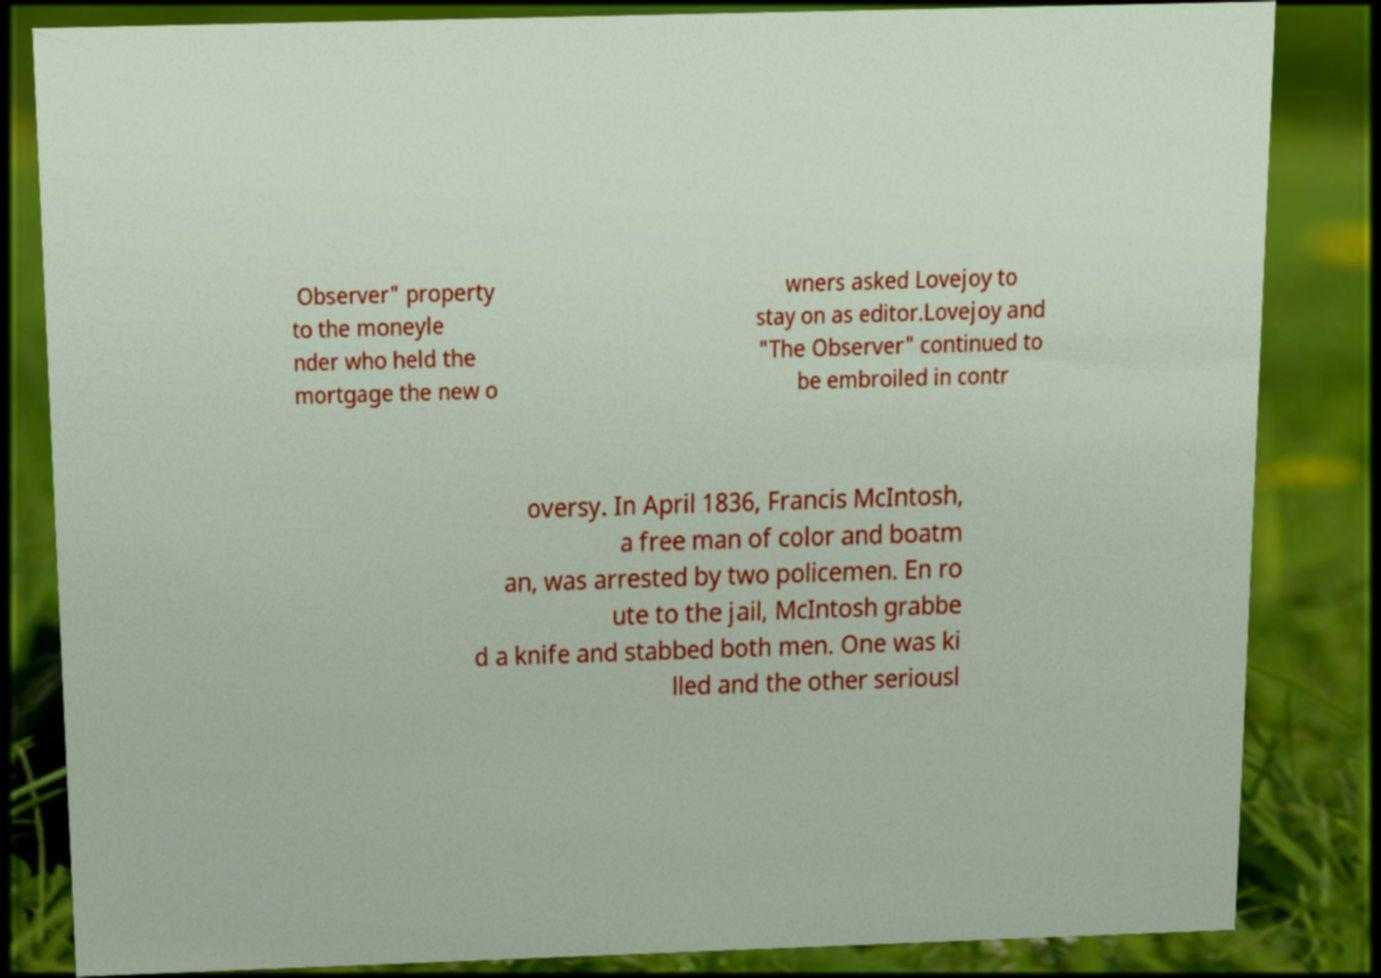There's text embedded in this image that I need extracted. Can you transcribe it verbatim? Observer" property to the moneyle nder who held the mortgage the new o wners asked Lovejoy to stay on as editor.Lovejoy and "The Observer" continued to be embroiled in contr oversy. In April 1836, Francis McIntosh, a free man of color and boatm an, was arrested by two policemen. En ro ute to the jail, McIntosh grabbe d a knife and stabbed both men. One was ki lled and the other seriousl 